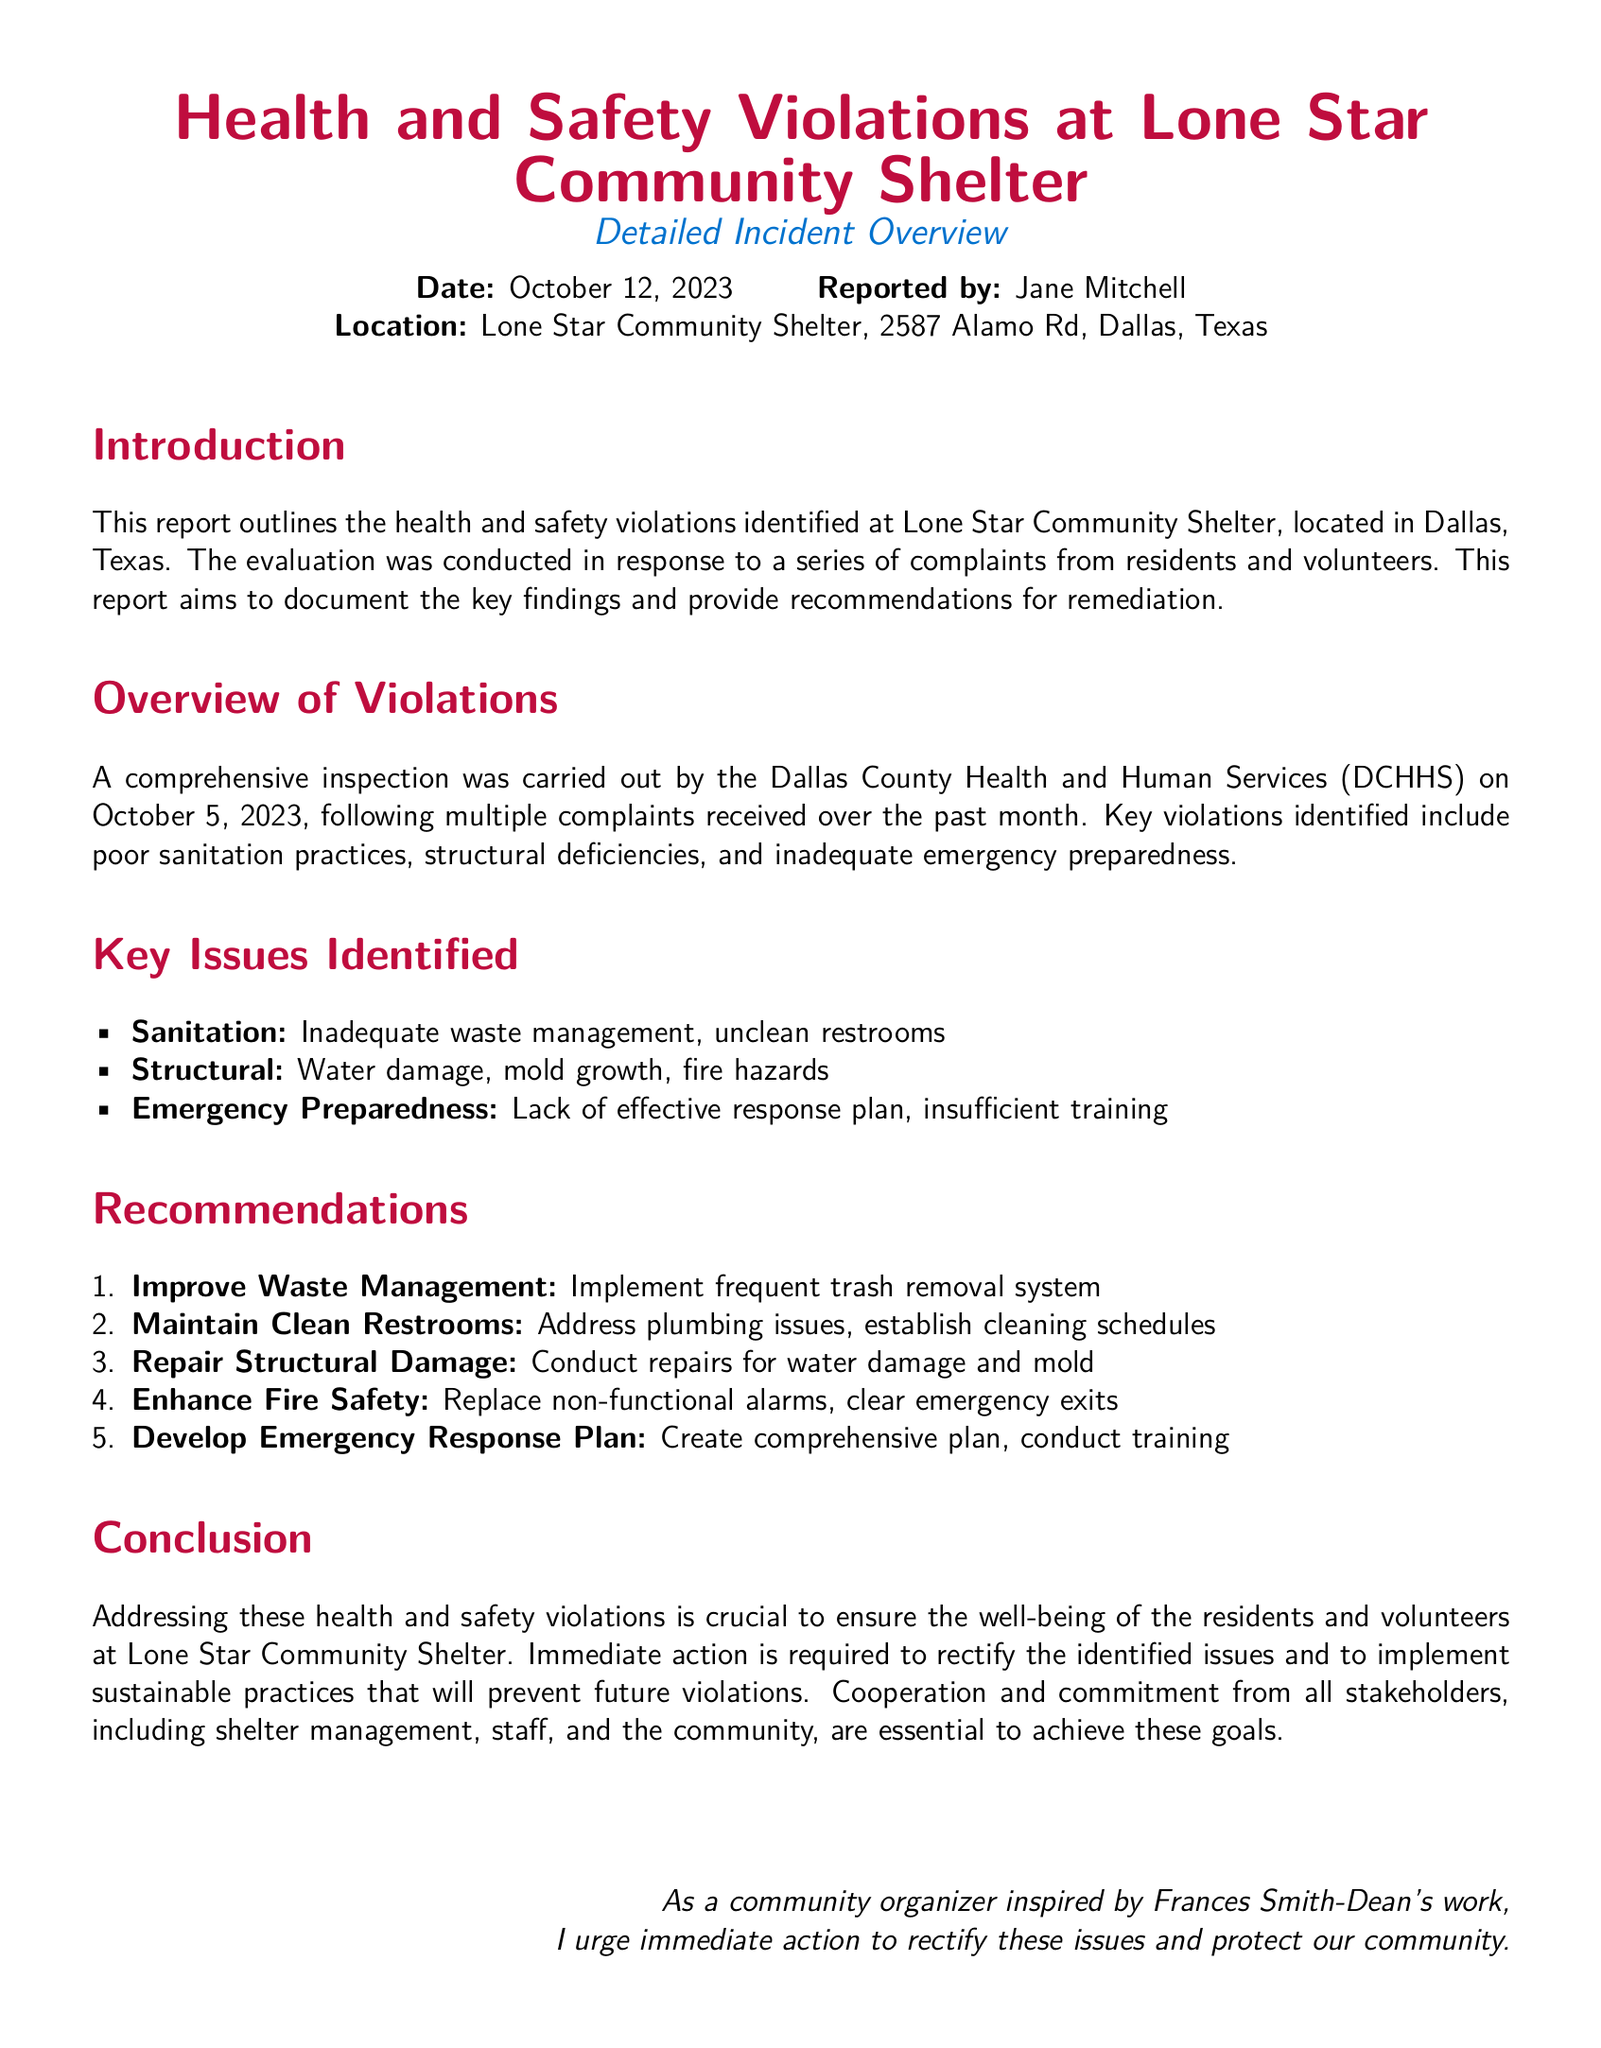What is the date of the report? The date of the report is listed at the beginning, indicating when the incident was documented.
Answer: October 12, 2023 Who reported the violations? The report specifies the name of the individual responsible for reporting the health and safety violations at the shelter.
Answer: Jane Mitchell What is one of the key issues identified? Key issues are outlined in the document under "Key Issues Identified," highlighting major concerns regarding the shelter’s conditions.
Answer: Inadequate waste management What should be implemented to improve waste management? The report contains recommendations for remediation, including specific actions necessary to address the identified issues related to waste.
Answer: Frequent trash removal system How many major health and safety violations were identified? The report discusses multiple violations but does not specify a numeric value, requiring reasoning to interpret the count from the issues listed.
Answer: Three What is one structural deficiency mentioned? The items under "Key Issues Identified" cover various structural problems found during inspection, focusing on safety concerns.
Answer: Mold growth What does the report suggest to enhance fire safety? There are specific recommendations provided for improving safety measures related to fire hazards within the shelter, directly addressing identified violations.
Answer: Replace non-functional alarms What is the location of the Lone Star Community Shelter? The report provides a full address for the shelter, which is essential for understanding where the violations occurred.
Answer: 2587 Alamo Rd, Dallas, Texas What type of document is this? The structure and content communicate a specific purpose relating to violations observed at a community facility, which defines its classification.
Answer: Incident report 